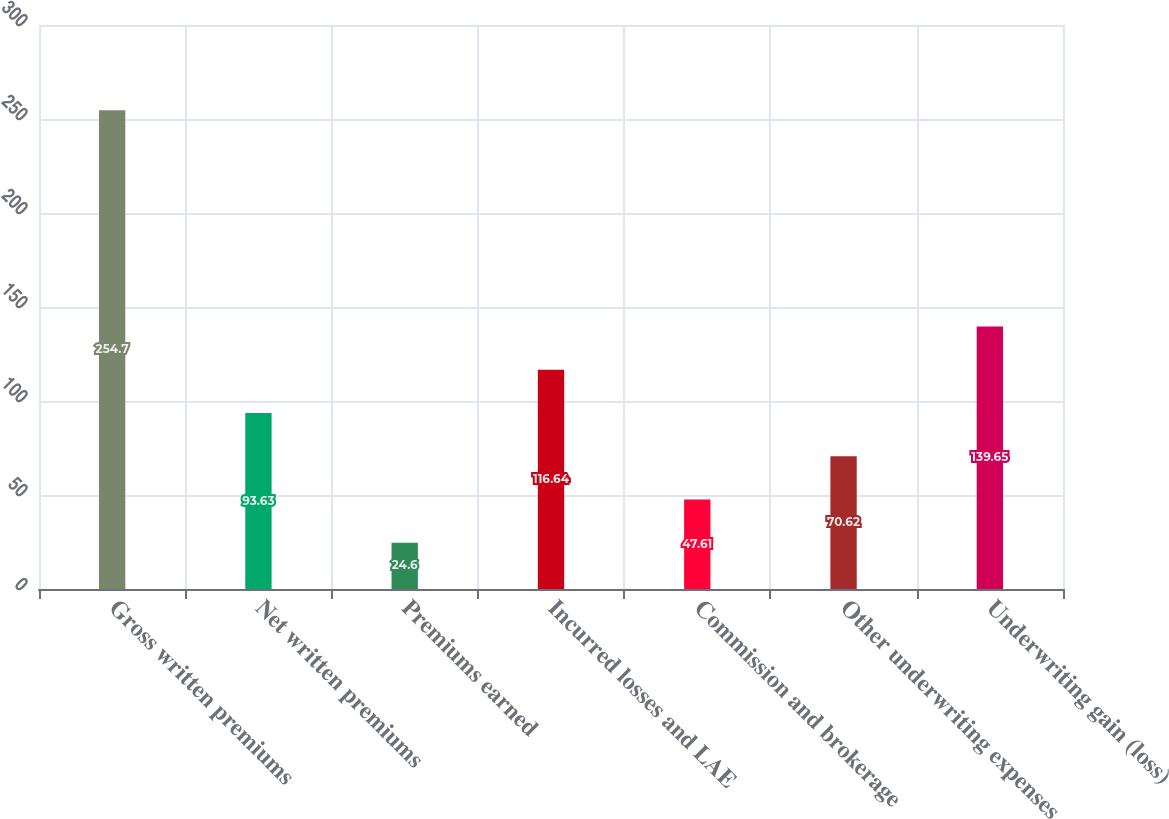Convert chart to OTSL. <chart><loc_0><loc_0><loc_500><loc_500><bar_chart><fcel>Gross written premiums<fcel>Net written premiums<fcel>Premiums earned<fcel>Incurred losses and LAE<fcel>Commission and brokerage<fcel>Other underwriting expenses<fcel>Underwriting gain (loss)<nl><fcel>254.7<fcel>93.63<fcel>24.6<fcel>116.64<fcel>47.61<fcel>70.62<fcel>139.65<nl></chart> 